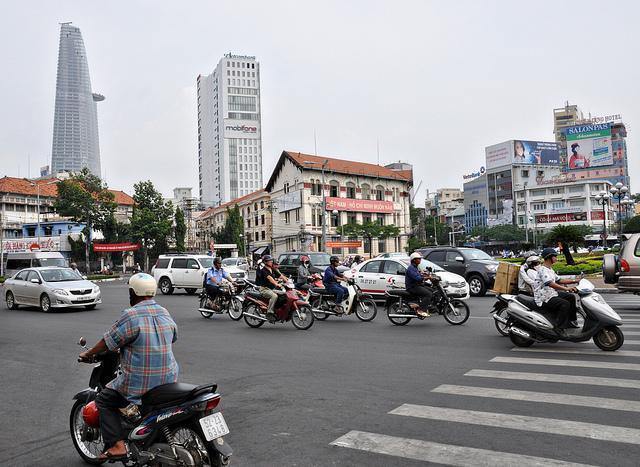How many motorcycles are there?
Give a very brief answer. 7. How many cars are there?
Give a very brief answer. 6. How many cars can you see?
Give a very brief answer. 2. How many people are there?
Give a very brief answer. 2. How many motorcycles can you see?
Give a very brief answer. 4. How many dogs are there?
Give a very brief answer. 0. 